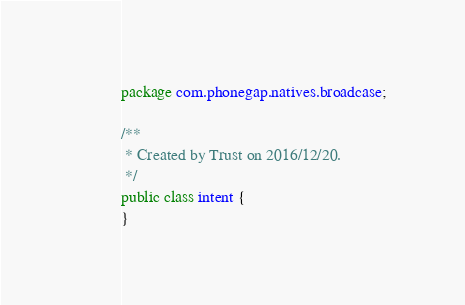Convert code to text. <code><loc_0><loc_0><loc_500><loc_500><_Java_>package com.phonegap.natives.broadcase;

/**
 * Created by Trust on 2016/12/20.
 */
public class intent {
}
</code> 